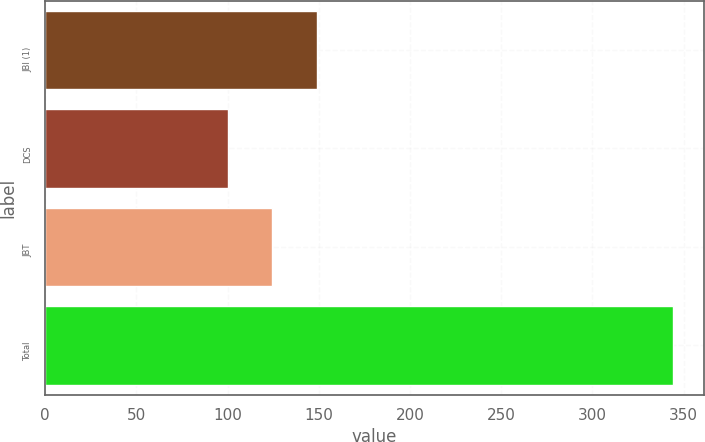Convert chart. <chart><loc_0><loc_0><loc_500><loc_500><bar_chart><fcel>JBI (1)<fcel>DCS<fcel>JBT<fcel>Total<nl><fcel>148.8<fcel>100<fcel>124.4<fcel>344<nl></chart> 